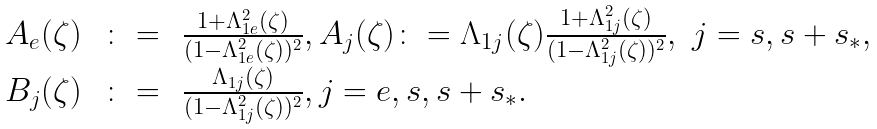<formula> <loc_0><loc_0><loc_500><loc_500>\begin{array} { r c l } A _ { e } ( \zeta ) & \, \colon = \, & \frac { 1 + \Lambda _ { 1 e } ^ { 2 } ( \zeta ) } { ( 1 - \Lambda _ { 1 e } ^ { 2 } ( \zeta ) ) ^ { 2 } } , A _ { j } ( \zeta ) \colon = \Lambda _ { 1 j } ( \zeta ) \frac { 1 + \Lambda _ { 1 j } ^ { 2 } ( \zeta ) } { ( 1 - \Lambda _ { 1 j } ^ { 2 } ( \zeta ) ) ^ { 2 } } , \ j = s , s + s _ { * } , \\ B _ { j } ( \zeta ) & \, \colon = \, & \frac { \Lambda _ { 1 j } ( \zeta ) } { ( 1 - \Lambda _ { 1 j } ^ { 2 } ( \zeta ) ) ^ { 2 } } , j = e , s , s + s _ { * } . \end{array}</formula> 